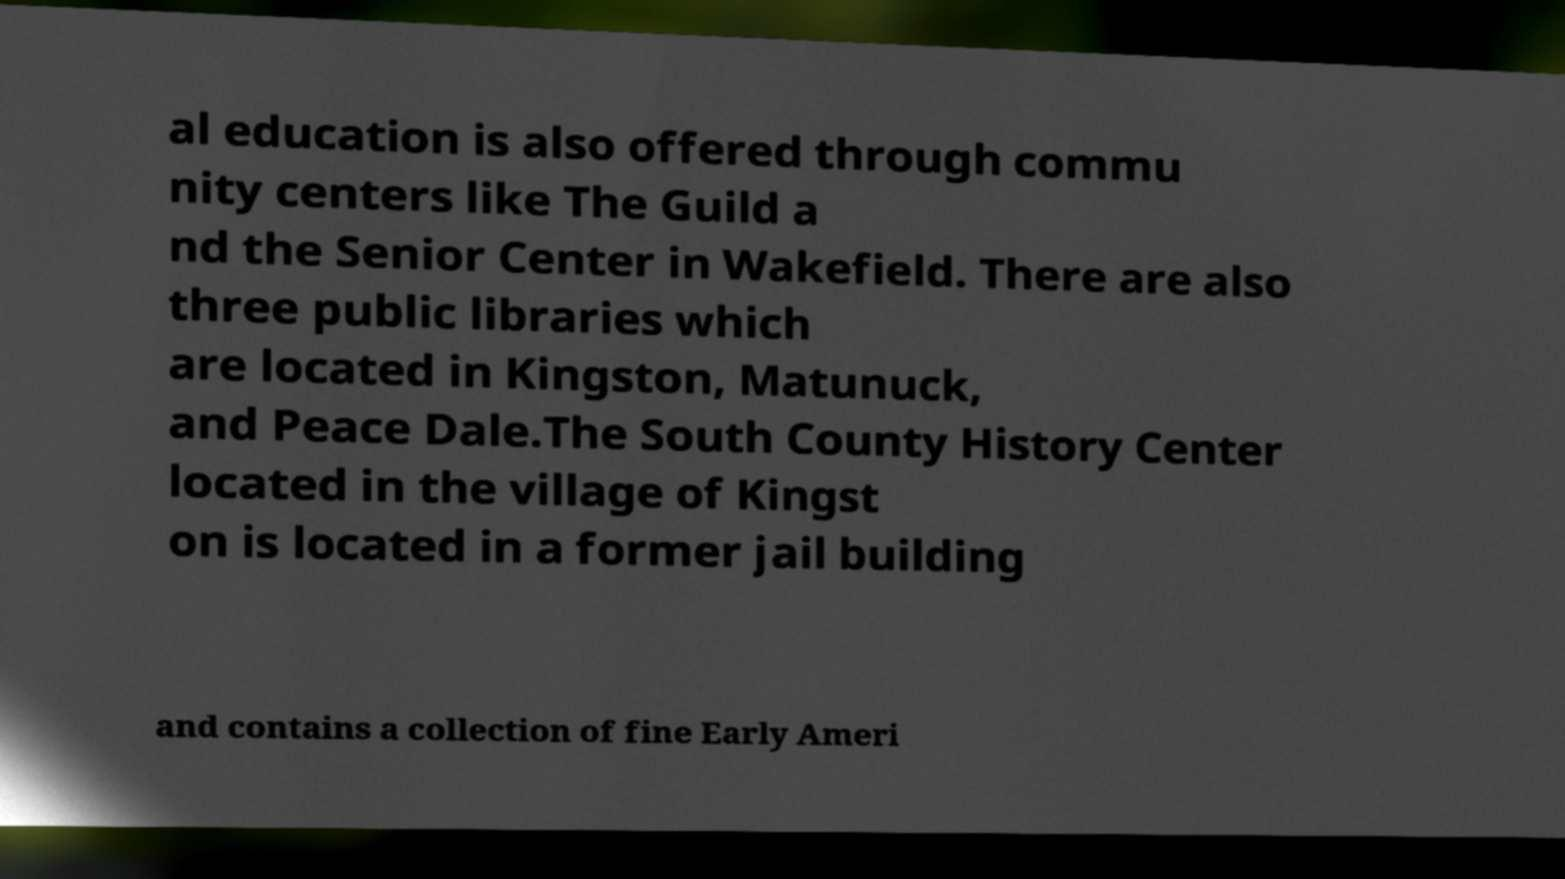Can you accurately transcribe the text from the provided image for me? al education is also offered through commu nity centers like The Guild a nd the Senior Center in Wakefield. There are also three public libraries which are located in Kingston, Matunuck, and Peace Dale.The South County History Center located in the village of Kingst on is located in a former jail building and contains a collection of fine Early Ameri 